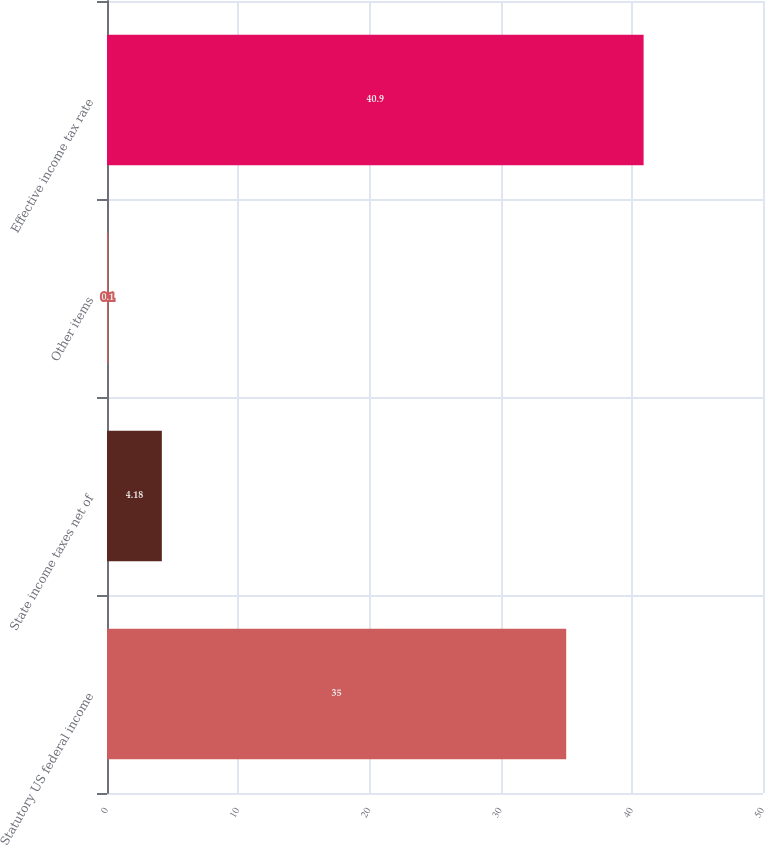<chart> <loc_0><loc_0><loc_500><loc_500><bar_chart><fcel>Statutory US federal income<fcel>State income taxes net of<fcel>Other items<fcel>Effective income tax rate<nl><fcel>35<fcel>4.18<fcel>0.1<fcel>40.9<nl></chart> 